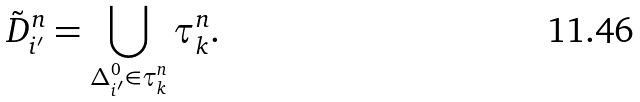Convert formula to latex. <formula><loc_0><loc_0><loc_500><loc_500>\tilde { D } ^ { n } _ { i ^ { \prime } } = \bigcup _ { \Delta ^ { 0 } _ { i ^ { \prime } } \in \tau ^ { n } _ { k } } \tau ^ { n } _ { k } .</formula> 